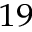<formula> <loc_0><loc_0><loc_500><loc_500>^ { 1 9 }</formula> 